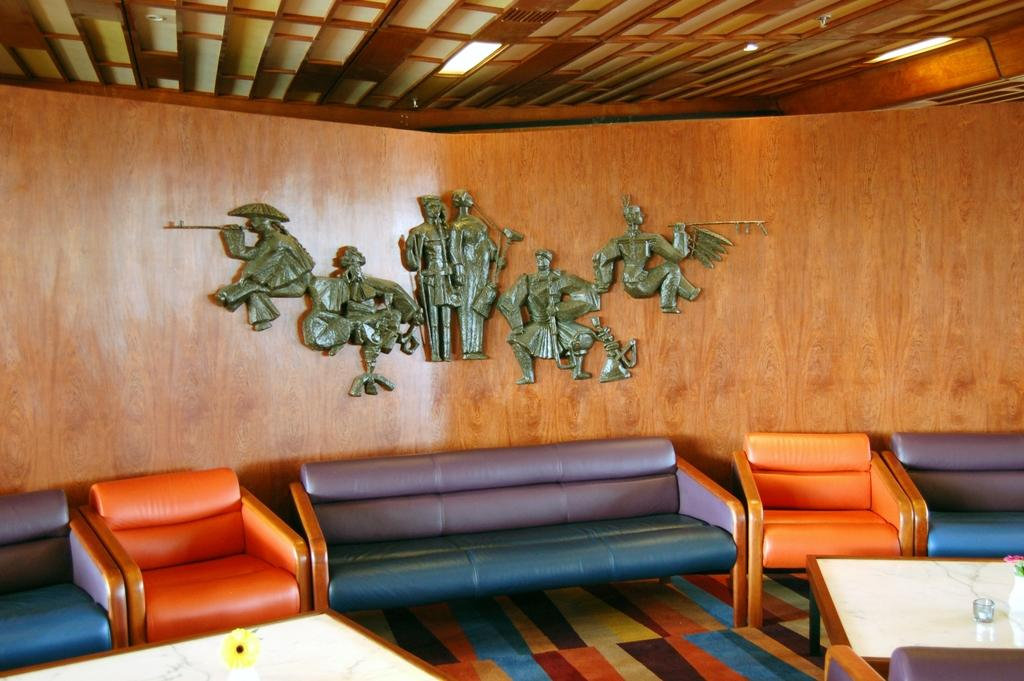What type of seating is available in the room? There are different colored sofas in the room. What is located in front of the sofas? There are two tables in front of the sofas. What is the wall behind the sofa made of? The wall behind the sofa is made of wood. What decorative items can be seen on the wooden wall? There are sculptures on the wooden wall. What type of reward is hanging from the scarf on the dirt in the image? There is no reward, scarf, or dirt present in the image. 